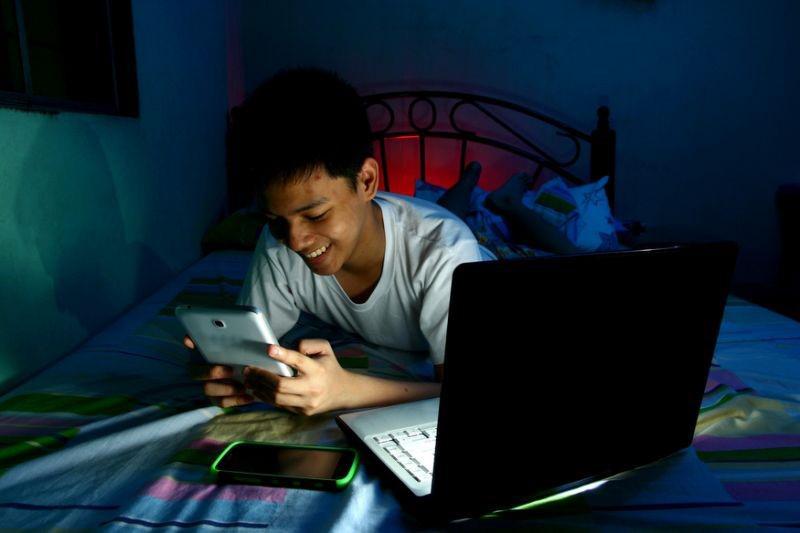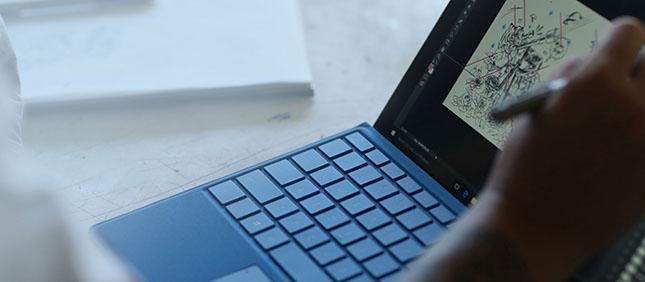The first image is the image on the left, the second image is the image on the right. For the images displayed, is the sentence "a masked man is viewing 3 monitors on a desk" factually correct? Answer yes or no. No. The first image is the image on the left, the second image is the image on the right. Evaluate the accuracy of this statement regarding the images: "In the left image, there's a man in a mask and hoodie typing on a keyboard with three monitors.". Is it true? Answer yes or no. No. 